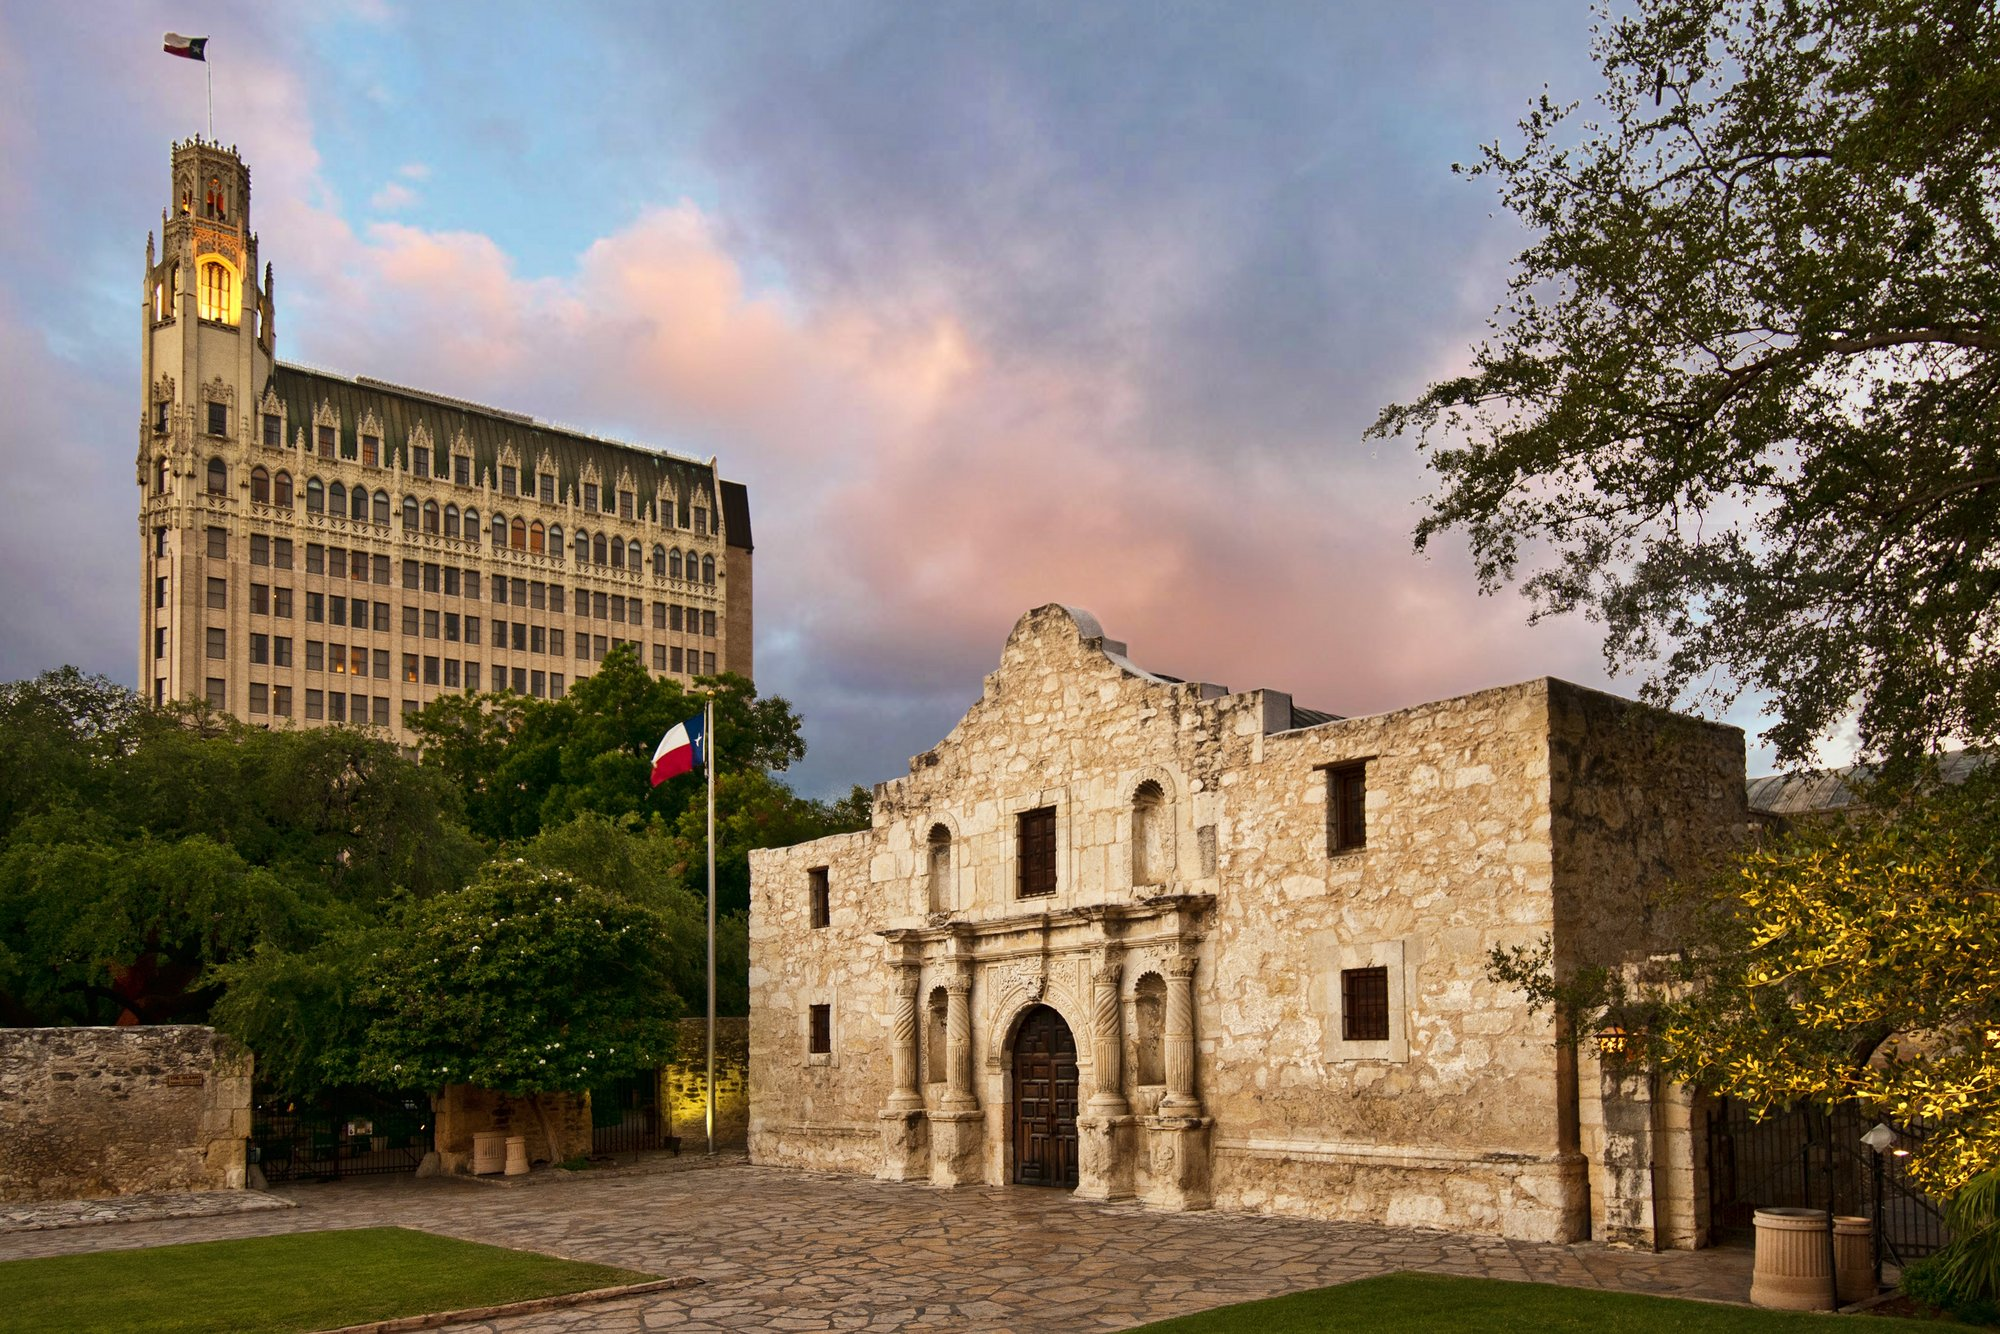Can you provide a casual summary of this image? This image shows the historic Alamo in San Antonio, Texas. It's a famous old building with distinct stone architecture and appears under a beautifully colored sky at dusk. A Texas flag is visible, and there's also a taller modern building in the background with a clock tower. 